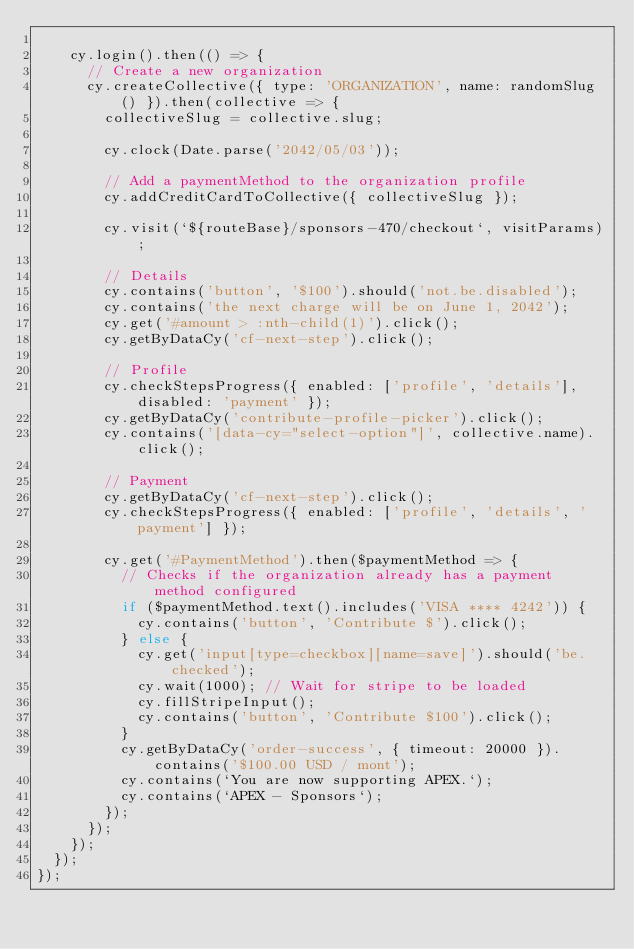<code> <loc_0><loc_0><loc_500><loc_500><_JavaScript_>
    cy.login().then(() => {
      // Create a new organization
      cy.createCollective({ type: 'ORGANIZATION', name: randomSlug() }).then(collective => {
        collectiveSlug = collective.slug;

        cy.clock(Date.parse('2042/05/03'));

        // Add a paymentMethod to the organization profile
        cy.addCreditCardToCollective({ collectiveSlug });

        cy.visit(`${routeBase}/sponsors-470/checkout`, visitParams);

        // Details
        cy.contains('button', '$100').should('not.be.disabled');
        cy.contains('the next charge will be on June 1, 2042');
        cy.get('#amount > :nth-child(1)').click();
        cy.getByDataCy('cf-next-step').click();

        // Profile
        cy.checkStepsProgress({ enabled: ['profile', 'details'], disabled: 'payment' });
        cy.getByDataCy('contribute-profile-picker').click();
        cy.contains('[data-cy="select-option"]', collective.name).click();

        // Payment
        cy.getByDataCy('cf-next-step').click();
        cy.checkStepsProgress({ enabled: ['profile', 'details', 'payment'] });

        cy.get('#PaymentMethod').then($paymentMethod => {
          // Checks if the organization already has a payment method configured
          if ($paymentMethod.text().includes('VISA **** 4242')) {
            cy.contains('button', 'Contribute $').click();
          } else {
            cy.get('input[type=checkbox][name=save]').should('be.checked');
            cy.wait(1000); // Wait for stripe to be loaded
            cy.fillStripeInput();
            cy.contains('button', 'Contribute $100').click();
          }
          cy.getByDataCy('order-success', { timeout: 20000 }).contains('$100.00 USD / mont');
          cy.contains(`You are now supporting APEX.`);
          cy.contains(`APEX - Sponsors`);
        });
      });
    });
  });
});
</code> 